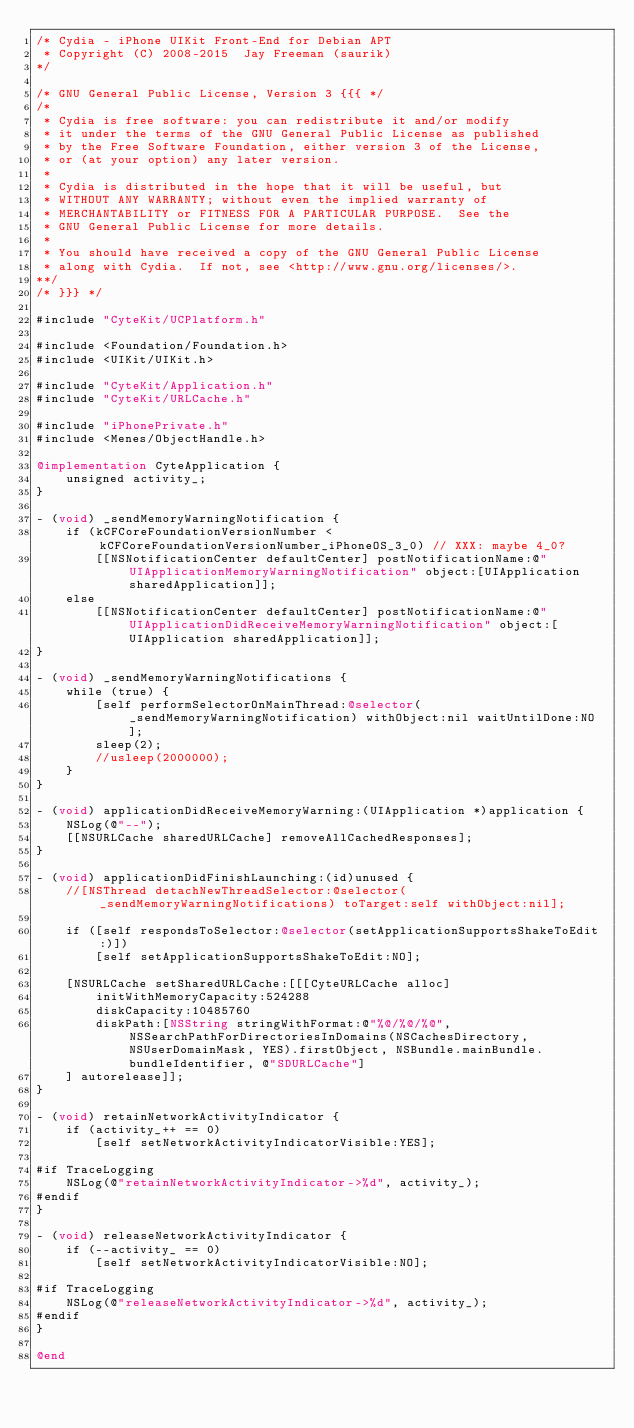<code> <loc_0><loc_0><loc_500><loc_500><_ObjectiveC_>/* Cydia - iPhone UIKit Front-End for Debian APT
 * Copyright (C) 2008-2015  Jay Freeman (saurik)
*/

/* GNU General Public License, Version 3 {{{ */
/*
 * Cydia is free software: you can redistribute it and/or modify
 * it under the terms of the GNU General Public License as published
 * by the Free Software Foundation, either version 3 of the License,
 * or (at your option) any later version.
 *
 * Cydia is distributed in the hope that it will be useful, but
 * WITHOUT ANY WARRANTY; without even the implied warranty of
 * MERCHANTABILITY or FITNESS FOR A PARTICULAR PURPOSE.  See the
 * GNU General Public License for more details.
 *
 * You should have received a copy of the GNU General Public License
 * along with Cydia.  If not, see <http://www.gnu.org/licenses/>.
**/
/* }}} */

#include "CyteKit/UCPlatform.h"

#include <Foundation/Foundation.h>
#include <UIKit/UIKit.h>

#include "CyteKit/Application.h"
#include "CyteKit/URLCache.h"

#include "iPhonePrivate.h"
#include <Menes/ObjectHandle.h>

@implementation CyteApplication {
    unsigned activity_;
}

- (void) _sendMemoryWarningNotification {
    if (kCFCoreFoundationVersionNumber < kCFCoreFoundationVersionNumber_iPhoneOS_3_0) // XXX: maybe 4_0?
        [[NSNotificationCenter defaultCenter] postNotificationName:@"UIApplicationMemoryWarningNotification" object:[UIApplication sharedApplication]];
    else
        [[NSNotificationCenter defaultCenter] postNotificationName:@"UIApplicationDidReceiveMemoryWarningNotification" object:[UIApplication sharedApplication]];
}

- (void) _sendMemoryWarningNotifications {
    while (true) {
        [self performSelectorOnMainThread:@selector(_sendMemoryWarningNotification) withObject:nil waitUntilDone:NO];
        sleep(2);
        //usleep(2000000);
    }
}

- (void) applicationDidReceiveMemoryWarning:(UIApplication *)application {
    NSLog(@"--");
    [[NSURLCache sharedURLCache] removeAllCachedResponses];
}

- (void) applicationDidFinishLaunching:(id)unused {
    //[NSThread detachNewThreadSelector:@selector(_sendMemoryWarningNotifications) toTarget:self withObject:nil];

    if ([self respondsToSelector:@selector(setApplicationSupportsShakeToEdit:)])
        [self setApplicationSupportsShakeToEdit:NO];

    [NSURLCache setSharedURLCache:[[[CyteURLCache alloc]
        initWithMemoryCapacity:524288
        diskCapacity:10485760
        diskPath:[NSString stringWithFormat:@"%@/%@/%@", NSSearchPathForDirectoriesInDomains(NSCachesDirectory, NSUserDomainMask, YES).firstObject, NSBundle.mainBundle.bundleIdentifier, @"SDURLCache"]
    ] autorelease]];
}

- (void) retainNetworkActivityIndicator {
    if (activity_++ == 0)
        [self setNetworkActivityIndicatorVisible:YES];

#if TraceLogging
    NSLog(@"retainNetworkActivityIndicator->%d", activity_);
#endif
}

- (void) releaseNetworkActivityIndicator {
    if (--activity_ == 0)
        [self setNetworkActivityIndicatorVisible:NO];

#if TraceLogging
    NSLog(@"releaseNetworkActivityIndicator->%d", activity_);
#endif
}

@end
</code> 